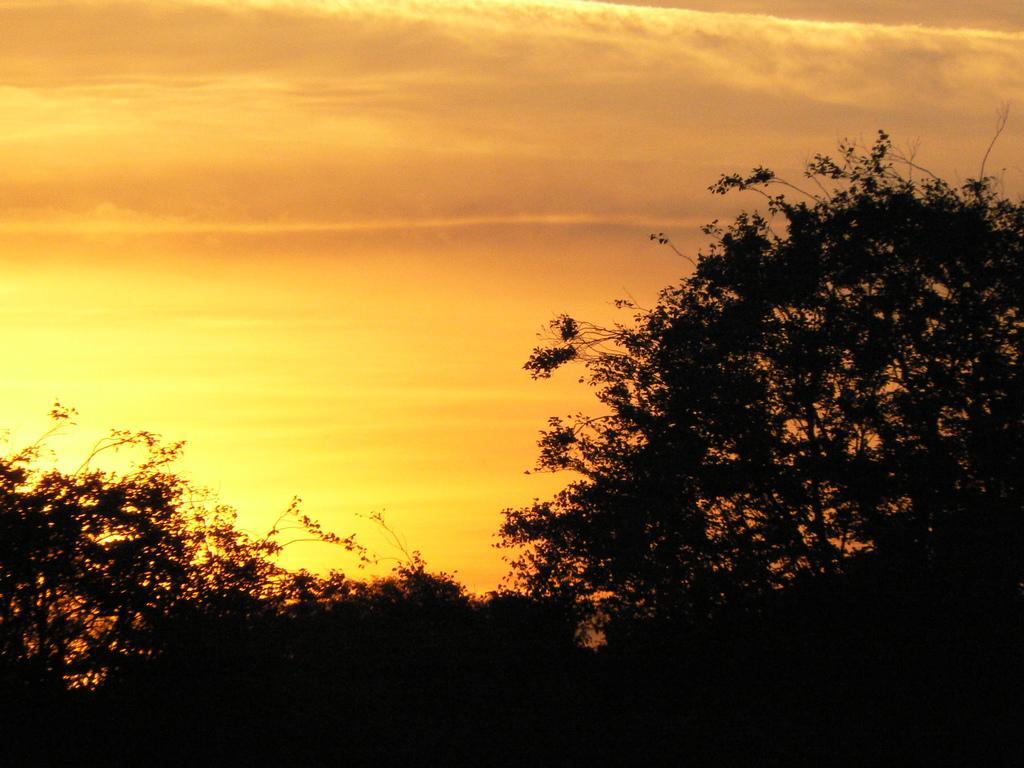Can you describe this image briefly? In this image I can see trees and there is sky. 